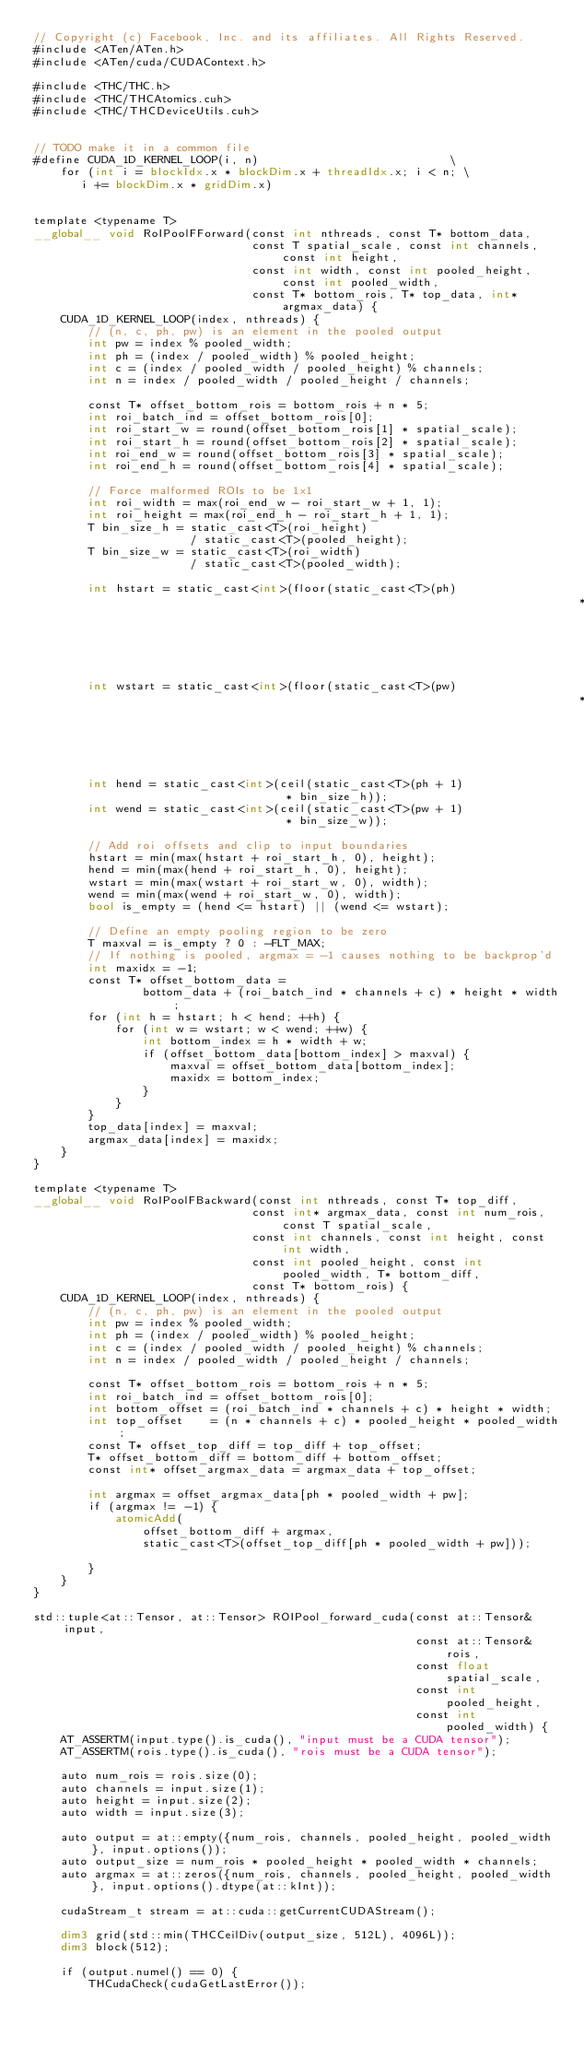Convert code to text. <code><loc_0><loc_0><loc_500><loc_500><_Cuda_>// Copyright (c) Facebook, Inc. and its affiliates. All Rights Reserved.
#include <ATen/ATen.h>
#include <ATen/cuda/CUDAContext.h>

#include <THC/THC.h>
#include <THC/THCAtomics.cuh>
#include <THC/THCDeviceUtils.cuh>


// TODO make it in a common file
#define CUDA_1D_KERNEL_LOOP(i, n)                            \
    for (int i = blockIdx.x * blockDim.x + threadIdx.x; i < n; \
       i += blockDim.x * gridDim.x)


template <typename T>
__global__ void RoIPoolFForward(const int nthreads, const T* bottom_data,
                                const T spatial_scale, const int channels, const int height,
                                const int width, const int pooled_height, const int pooled_width,
                                const T* bottom_rois, T* top_data, int* argmax_data) {
    CUDA_1D_KERNEL_LOOP(index, nthreads) {
        // (n, c, ph, pw) is an element in the pooled output
        int pw = index % pooled_width;
        int ph = (index / pooled_width) % pooled_height;
        int c = (index / pooled_width / pooled_height) % channels;
        int n = index / pooled_width / pooled_height / channels;

        const T* offset_bottom_rois = bottom_rois + n * 5;
        int roi_batch_ind = offset_bottom_rois[0];
        int roi_start_w = round(offset_bottom_rois[1] * spatial_scale);
        int roi_start_h = round(offset_bottom_rois[2] * spatial_scale);
        int roi_end_w = round(offset_bottom_rois[3] * spatial_scale);
        int roi_end_h = round(offset_bottom_rois[4] * spatial_scale);

        // Force malformed ROIs to be 1x1
        int roi_width = max(roi_end_w - roi_start_w + 1, 1);
        int roi_height = max(roi_end_h - roi_start_h + 1, 1);
        T bin_size_h = static_cast<T>(roi_height)
                       / static_cast<T>(pooled_height);
        T bin_size_w = static_cast<T>(roi_width)
                       / static_cast<T>(pooled_width);

        int hstart = static_cast<int>(floor(static_cast<T>(ph)
                                                                                * bin_size_h));
        int wstart = static_cast<int>(floor(static_cast<T>(pw)
                                                                                * bin_size_w));
        int hend = static_cast<int>(ceil(static_cast<T>(ph + 1)
                                     * bin_size_h));
        int wend = static_cast<int>(ceil(static_cast<T>(pw + 1)
                                     * bin_size_w));

        // Add roi offsets and clip to input boundaries
        hstart = min(max(hstart + roi_start_h, 0), height);
        hend = min(max(hend + roi_start_h, 0), height);
        wstart = min(max(wstart + roi_start_w, 0), width);
        wend = min(max(wend + roi_start_w, 0), width);
        bool is_empty = (hend <= hstart) || (wend <= wstart);

        // Define an empty pooling region to be zero
        T maxval = is_empty ? 0 : -FLT_MAX;
        // If nothing is pooled, argmax = -1 causes nothing to be backprop'd
        int maxidx = -1;
        const T* offset_bottom_data =
                bottom_data + (roi_batch_ind * channels + c) * height * width;
        for (int h = hstart; h < hend; ++h) {
            for (int w = wstart; w < wend; ++w) {
                int bottom_index = h * width + w;
                if (offset_bottom_data[bottom_index] > maxval) {
                    maxval = offset_bottom_data[bottom_index];
                    maxidx = bottom_index;
                }
            }
        }
        top_data[index] = maxval;
        argmax_data[index] = maxidx;
    }
}

template <typename T>
__global__ void RoIPoolFBackward(const int nthreads, const T* top_diff,
                                const int* argmax_data, const int num_rois, const T spatial_scale,
                                const int channels, const int height, const int width,
                                const int pooled_height, const int pooled_width, T* bottom_diff,
                                const T* bottom_rois) {
    CUDA_1D_KERNEL_LOOP(index, nthreads) {
        // (n, c, ph, pw) is an element in the pooled output
        int pw = index % pooled_width;
        int ph = (index / pooled_width) % pooled_height;
        int c = (index / pooled_width / pooled_height) % channels;
        int n = index / pooled_width / pooled_height / channels;

        const T* offset_bottom_rois = bottom_rois + n * 5;
        int roi_batch_ind = offset_bottom_rois[0];
        int bottom_offset = (roi_batch_ind * channels + c) * height * width;
        int top_offset    = (n * channels + c) * pooled_height * pooled_width;
        const T* offset_top_diff = top_diff + top_offset;
        T* offset_bottom_diff = bottom_diff + bottom_offset;
        const int* offset_argmax_data = argmax_data + top_offset;

        int argmax = offset_argmax_data[ph * pooled_width + pw];
        if (argmax != -1) {
            atomicAdd(
                offset_bottom_diff + argmax,
                static_cast<T>(offset_top_diff[ph * pooled_width + pw]));

        }
    }
}

std::tuple<at::Tensor, at::Tensor> ROIPool_forward_cuda(const at::Tensor& input,
                                                        const at::Tensor& rois,
                                                        const float spatial_scale,
                                                        const int pooled_height,
                                                        const int pooled_width) {
    AT_ASSERTM(input.type().is_cuda(), "input must be a CUDA tensor");
    AT_ASSERTM(rois.type().is_cuda(), "rois must be a CUDA tensor");

    auto num_rois = rois.size(0);
    auto channels = input.size(1);
    auto height = input.size(2);
    auto width = input.size(3);

    auto output = at::empty({num_rois, channels, pooled_height, pooled_width}, input.options());
    auto output_size = num_rois * pooled_height * pooled_width * channels;
    auto argmax = at::zeros({num_rois, channels, pooled_height, pooled_width}, input.options().dtype(at::kInt));

    cudaStream_t stream = at::cuda::getCurrentCUDAStream();

    dim3 grid(std::min(THCCeilDiv(output_size, 512L), 4096L));
    dim3 block(512);

    if (output.numel() == 0) {
        THCudaCheck(cudaGetLastError());</code> 